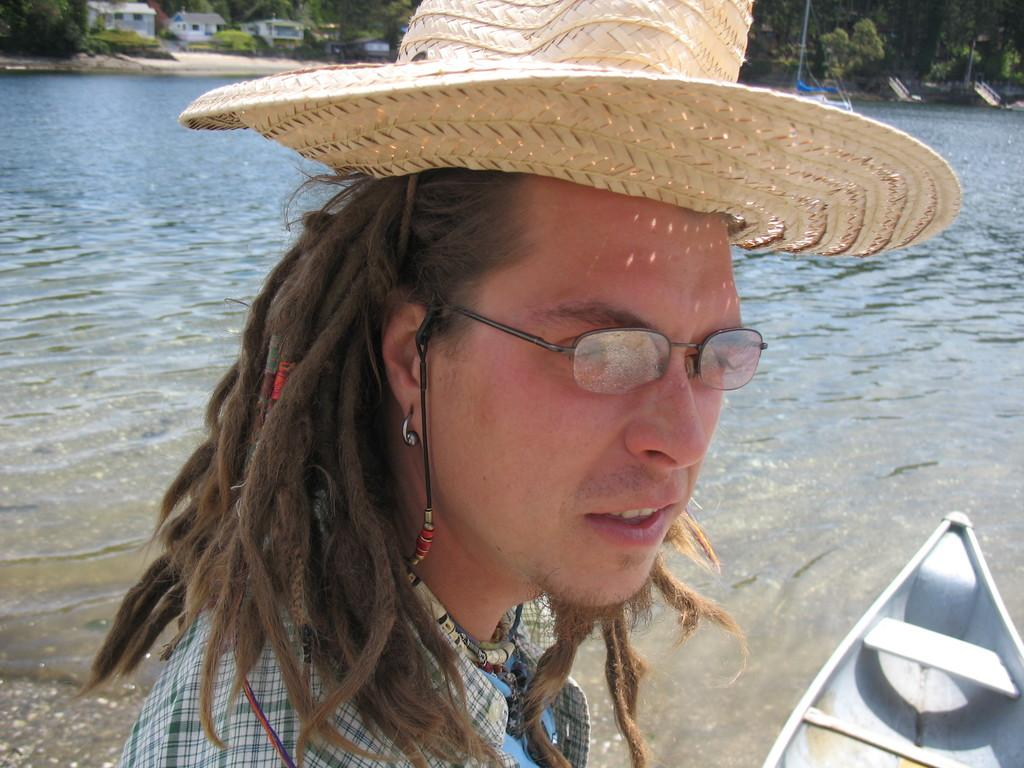What can be seen in the image? There is a person in the image, and there is a boat on the water. Can you describe the person in the image? The person is wearing a hat and specs. What is visible in the background of the image? There are trees and buildings in the background of the image. What idea does the person have about smashing the boat in the image? There is no indication in the image that the person has any idea about smashing the boat, as the image does not show any such action or intention. 